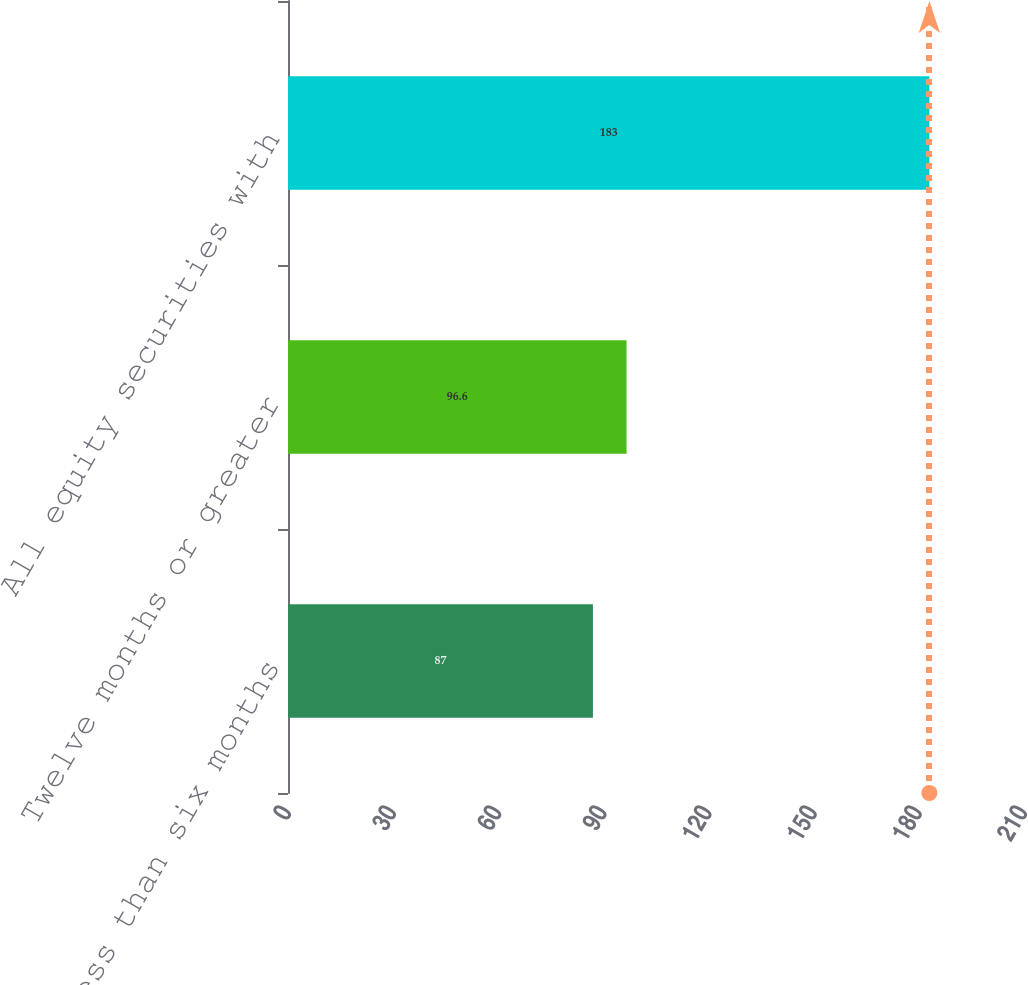Convert chart. <chart><loc_0><loc_0><loc_500><loc_500><bar_chart><fcel>Less than six months<fcel>Twelve months or greater<fcel>All equity securities with<nl><fcel>87<fcel>96.6<fcel>183<nl></chart> 